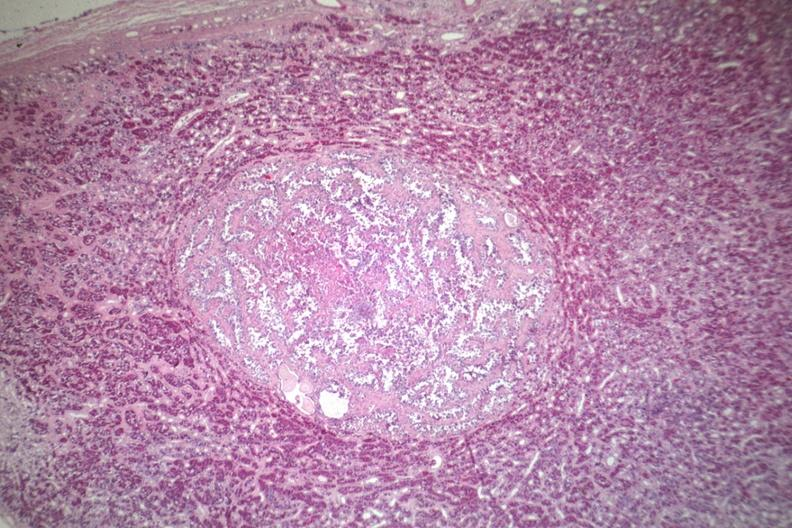s tuberculosis present?
Answer the question using a single word or phrase. No 